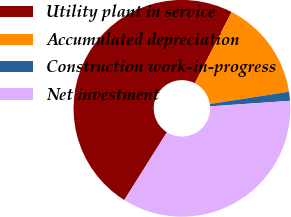Convert chart to OTSL. <chart><loc_0><loc_0><loc_500><loc_500><pie_chart><fcel>Utility plant in service<fcel>Accumulated depreciation<fcel>Construction work-in-progress<fcel>Net investment<nl><fcel>48.66%<fcel>14.97%<fcel>1.34%<fcel>35.03%<nl></chart> 